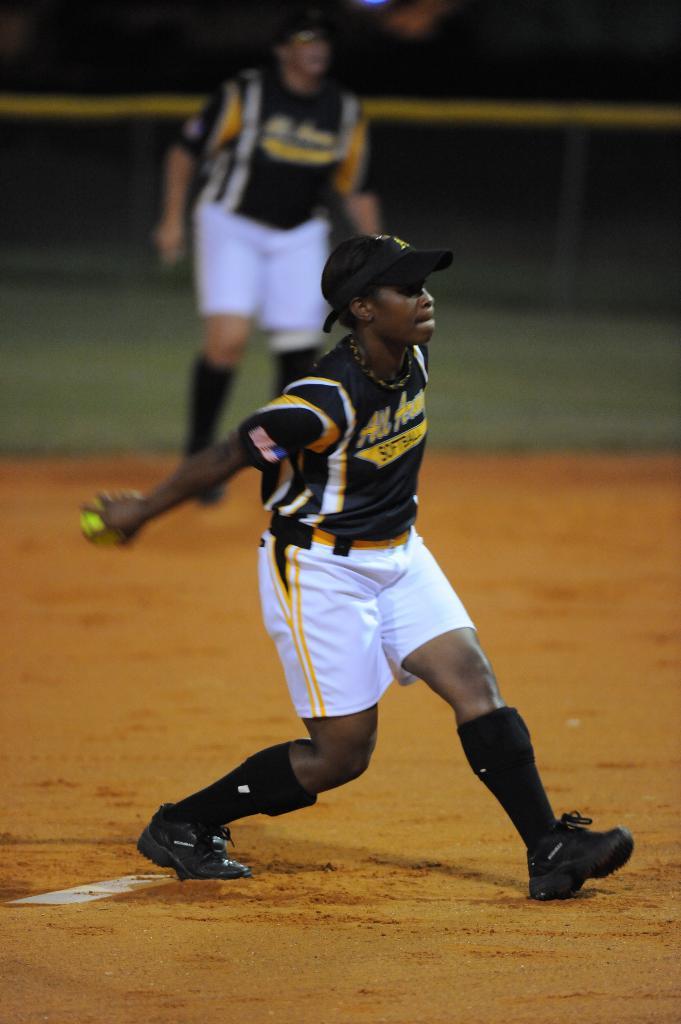What sport is this boy playing?
Make the answer very short. Answering does not require reading text in the image. What is the first word on the jersey?
Provide a short and direct response. All. 